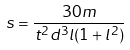<formula> <loc_0><loc_0><loc_500><loc_500>s = \frac { 3 0 m } { t ^ { 2 } d ^ { 3 } l ( 1 + l ^ { 2 } ) }</formula> 